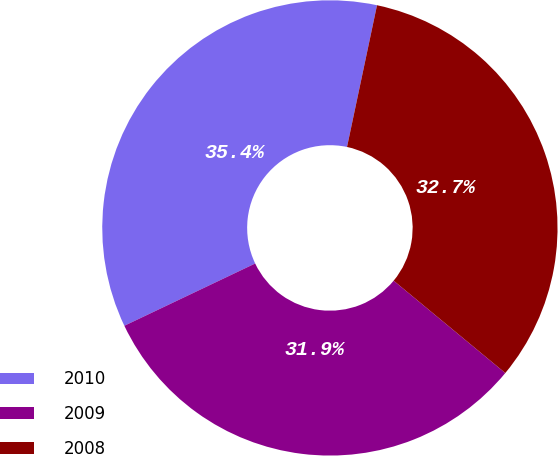<chart> <loc_0><loc_0><loc_500><loc_500><pie_chart><fcel>2010<fcel>2009<fcel>2008<nl><fcel>35.39%<fcel>31.93%<fcel>32.68%<nl></chart> 